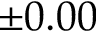<formula> <loc_0><loc_0><loc_500><loc_500>\pm 0 . 0 0</formula> 